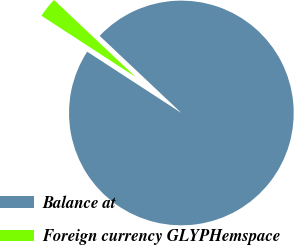<chart> <loc_0><loc_0><loc_500><loc_500><pie_chart><fcel>Balance at<fcel>Foreign currency GLYPHemspace<nl><fcel>97.14%<fcel>2.86%<nl></chart> 